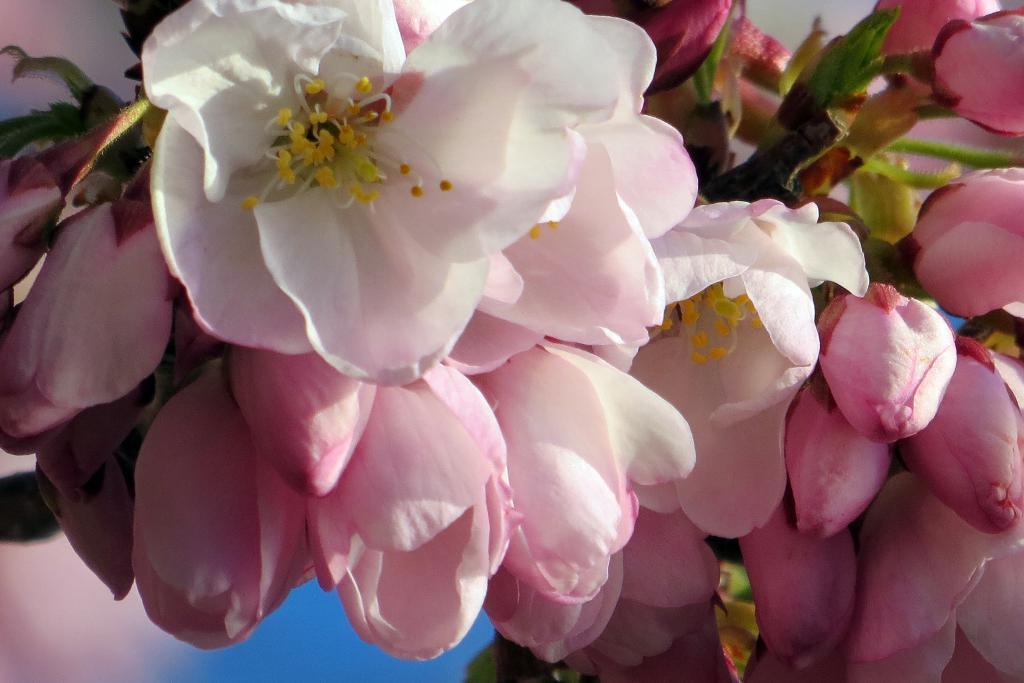What is located in the foreground of the image? There are flowers in the foreground of the image. Can you describe the background of the image? The background of the image is blurred. What type of doll is sitting on the coach in the image? There is no doll or coach present in the image; it only features flowers in the foreground and a blurred background. How many roses can be seen in the image? The image does not specify the type of flowers, so it cannot be determined if any of them are roses. 